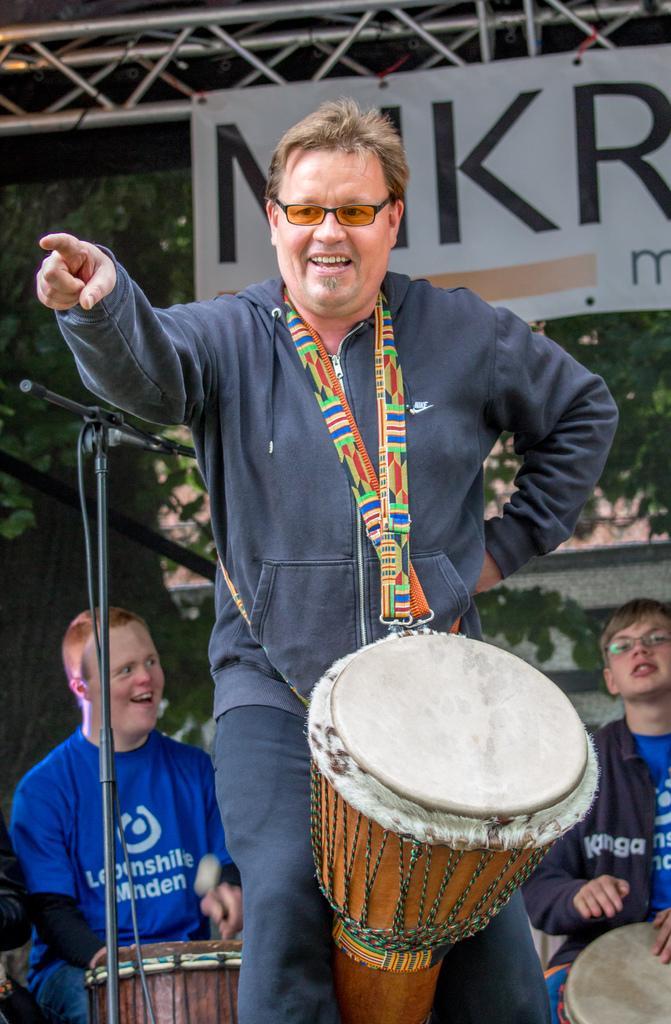In one or two sentences, can you explain what this image depicts? In the center we can see one man standing and he is smiling and he is holding drum. In the background there is a banner,trees,microphone and two persons were sitting on the chair. 